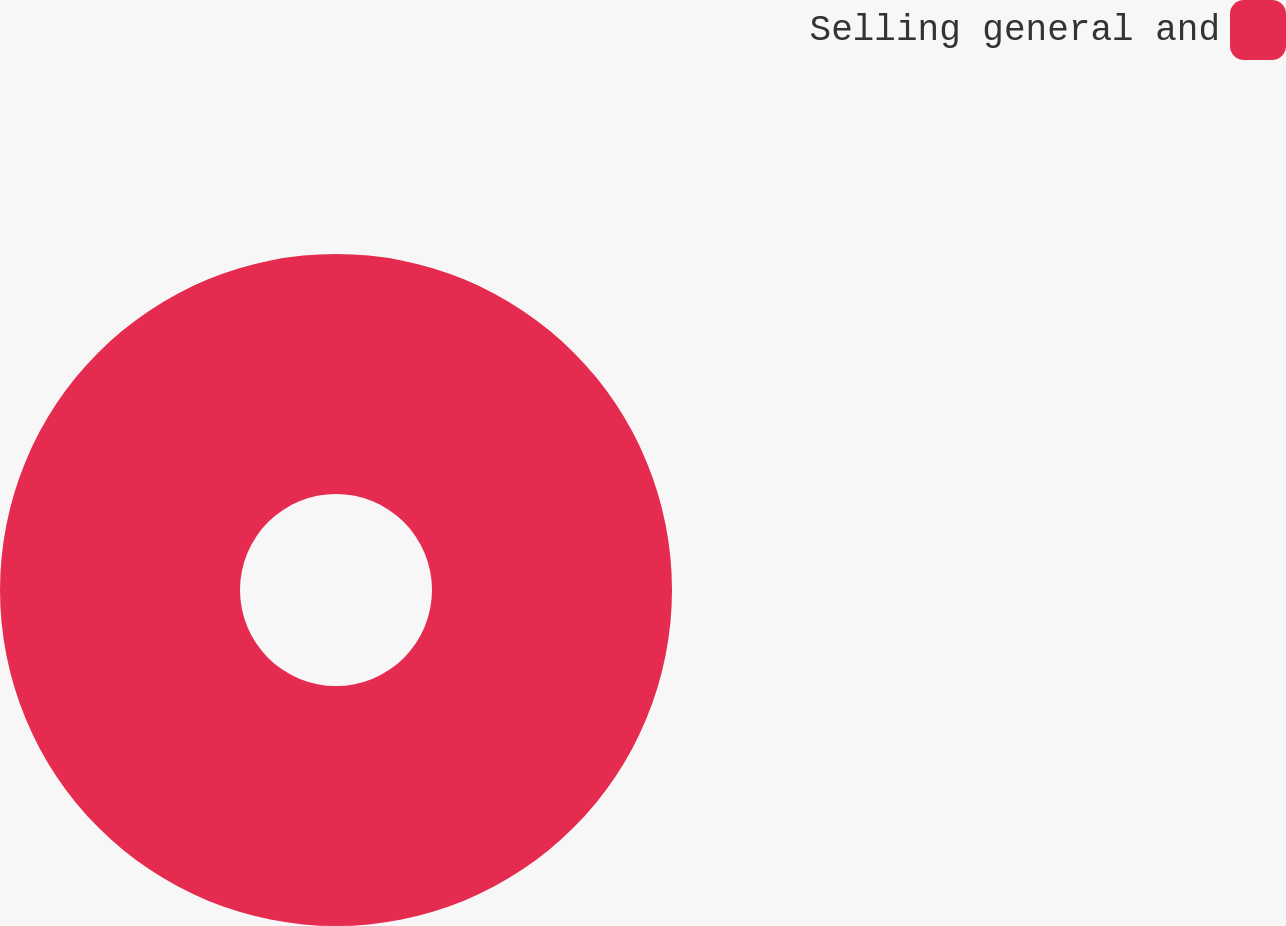Convert chart to OTSL. <chart><loc_0><loc_0><loc_500><loc_500><pie_chart><fcel>Selling general and<nl><fcel>100.0%<nl></chart> 